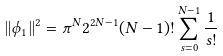Convert formula to latex. <formula><loc_0><loc_0><loc_500><loc_500>| | \phi _ { 1 } | | ^ { 2 } = \pi ^ { N } 2 ^ { 2 N - 1 } ( N - 1 ) ! \sum _ { s = 0 } ^ { N - 1 } \frac { 1 } { s ! }</formula> 